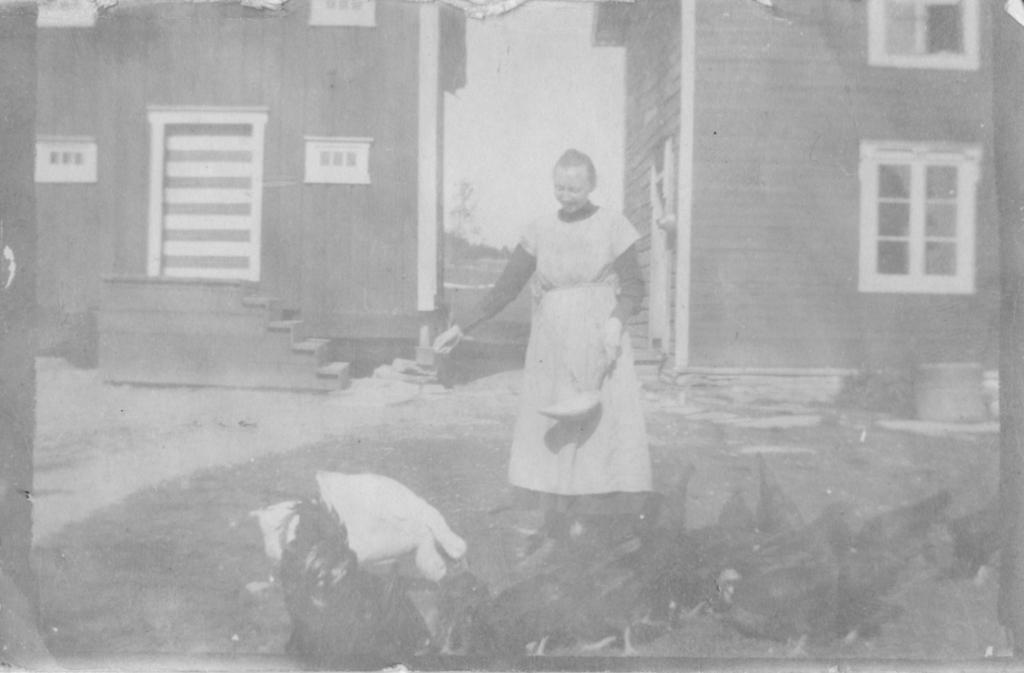What is the color scheme of the image? The image is black and white. Who is present in the image? There is a woman standing in the image. What is the woman standing on? The woman is standing on the ground. What can be seen in front of the woman? There are birds in front of the woman. What type of structures are visible in the background of the image? There are houses in the background of the image. Can you see the woman's veins in the image? No, you cannot see the woman's veins in the image, as it is black and white. --- Facts: 1. There is a car in the image. 2. The car is red. 3. The car has four wheels. 4. There are people standing near the car. 5. The car has a trunk. Absurd Topics: unicorn, basketball Conversation: What is the main subject in the image? There is a car in the image. What color is the car? The car is red. How many wheels does the car have? The car has four wheels. What can be seen near the car? There are people standing near the car. What feature does the car have? The car has a trunk. Reasoning: Let's think step by step in order to produce the conversation. We start by identifying the main subject of the image, which is the car. Next, we describe specific features of the car, such as its color and the number of wheels it has. Then, we observe the actions of the people in the image, noting that they are standing near the car. Finally, we describe another feature of the car, which is the trunk. Absurd Question/Answer: Can you see a unicorn playing basketball with the people standing near the car in the image? No, you cannot see a unicorn playing basketball with the people standing near the car in the image, as there is no mention of a unicorn or basketball in the provided facts. 